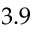Convert formula to latex. <formula><loc_0><loc_0><loc_500><loc_500>3 . 9</formula> 